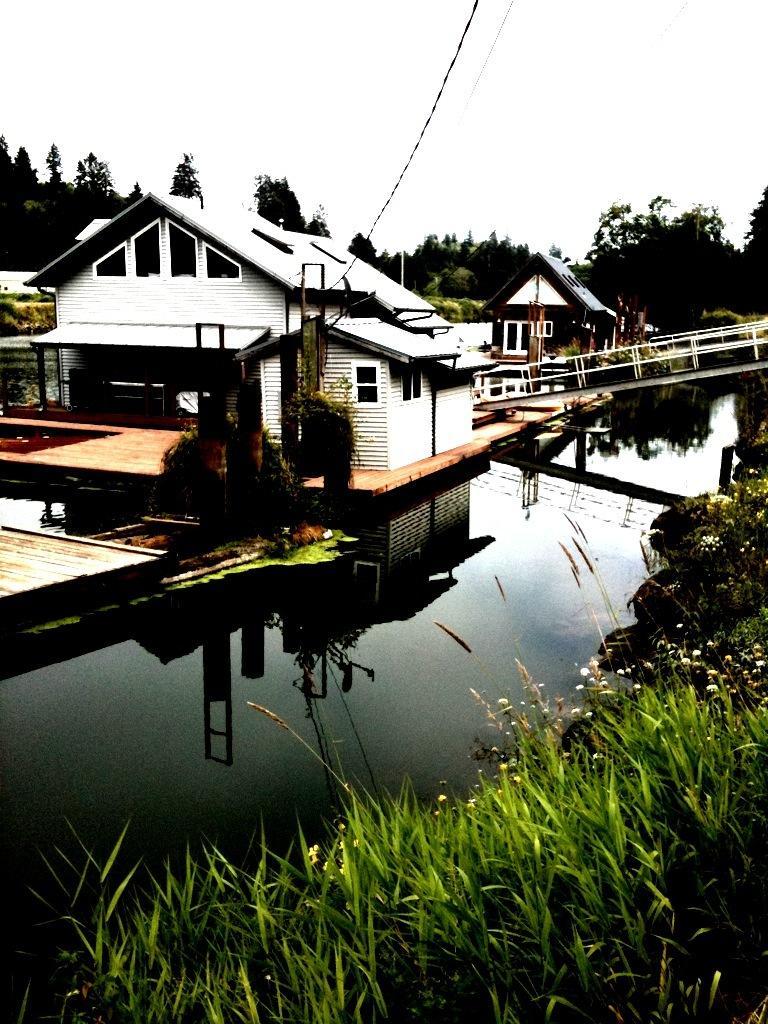Could you give a brief overview of what you see in this image? In this image I can see building on the water, beside that there are water, trees and plants. 